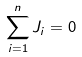<formula> <loc_0><loc_0><loc_500><loc_500>\sum _ { i = 1 } ^ { n } { J _ { i } } = 0</formula> 